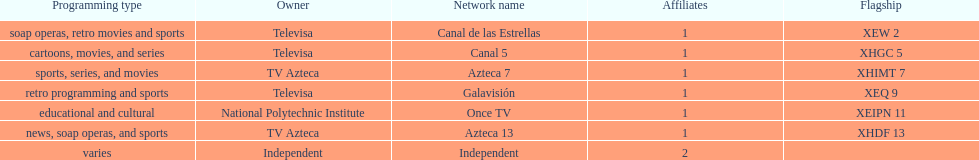How many networks does tv azteca own? 2. I'm looking to parse the entire table for insights. Could you assist me with that? {'header': ['Programming type', 'Owner', 'Network name', 'Affiliates', 'Flagship'], 'rows': [['soap operas, retro movies and sports', 'Televisa', 'Canal de las Estrellas', '1', 'XEW 2'], ['cartoons, movies, and series', 'Televisa', 'Canal 5', '1', 'XHGC 5'], ['sports, series, and movies', 'TV Azteca', 'Azteca 7', '1', 'XHIMT 7'], ['retro programming and sports', 'Televisa', 'Galavisión', '1', 'XEQ 9'], ['educational and cultural', 'National Polytechnic Institute', 'Once TV', '1', 'XEIPN 11'], ['news, soap operas, and sports', 'TV Azteca', 'Azteca 13', '1', 'XHDF 13'], ['varies', 'Independent', 'Independent', '2', '']]} 